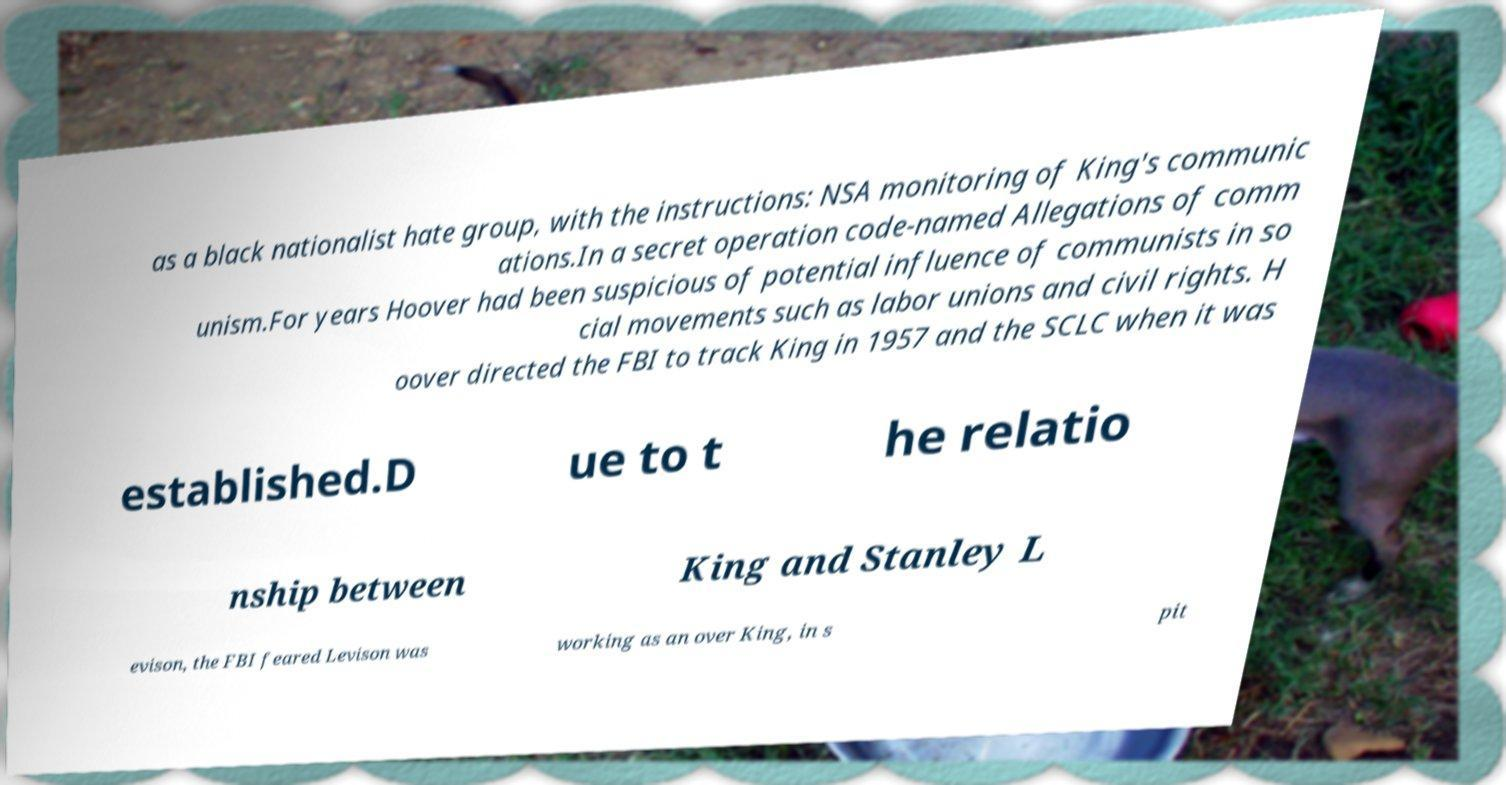Could you assist in decoding the text presented in this image and type it out clearly? as a black nationalist hate group, with the instructions: NSA monitoring of King's communic ations.In a secret operation code-named Allegations of comm unism.For years Hoover had been suspicious of potential influence of communists in so cial movements such as labor unions and civil rights. H oover directed the FBI to track King in 1957 and the SCLC when it was established.D ue to t he relatio nship between King and Stanley L evison, the FBI feared Levison was working as an over King, in s pit 